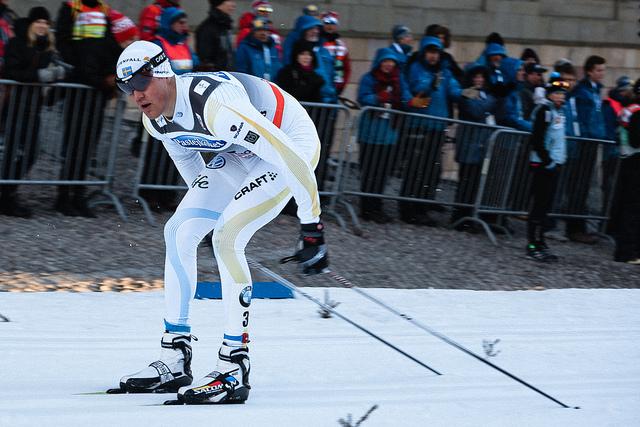What color is the man's uniform?
Concise answer only. White. What is the man doing?
Be succinct. Skiing. What are the spectator's standing behind?
Answer briefly. Fence. 